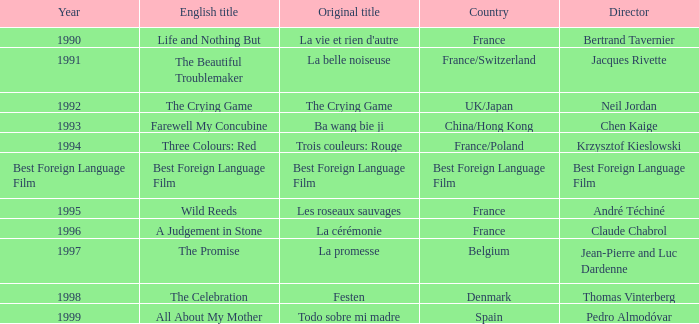Which Country is listed for the Director Thomas Vinterberg? Denmark. 